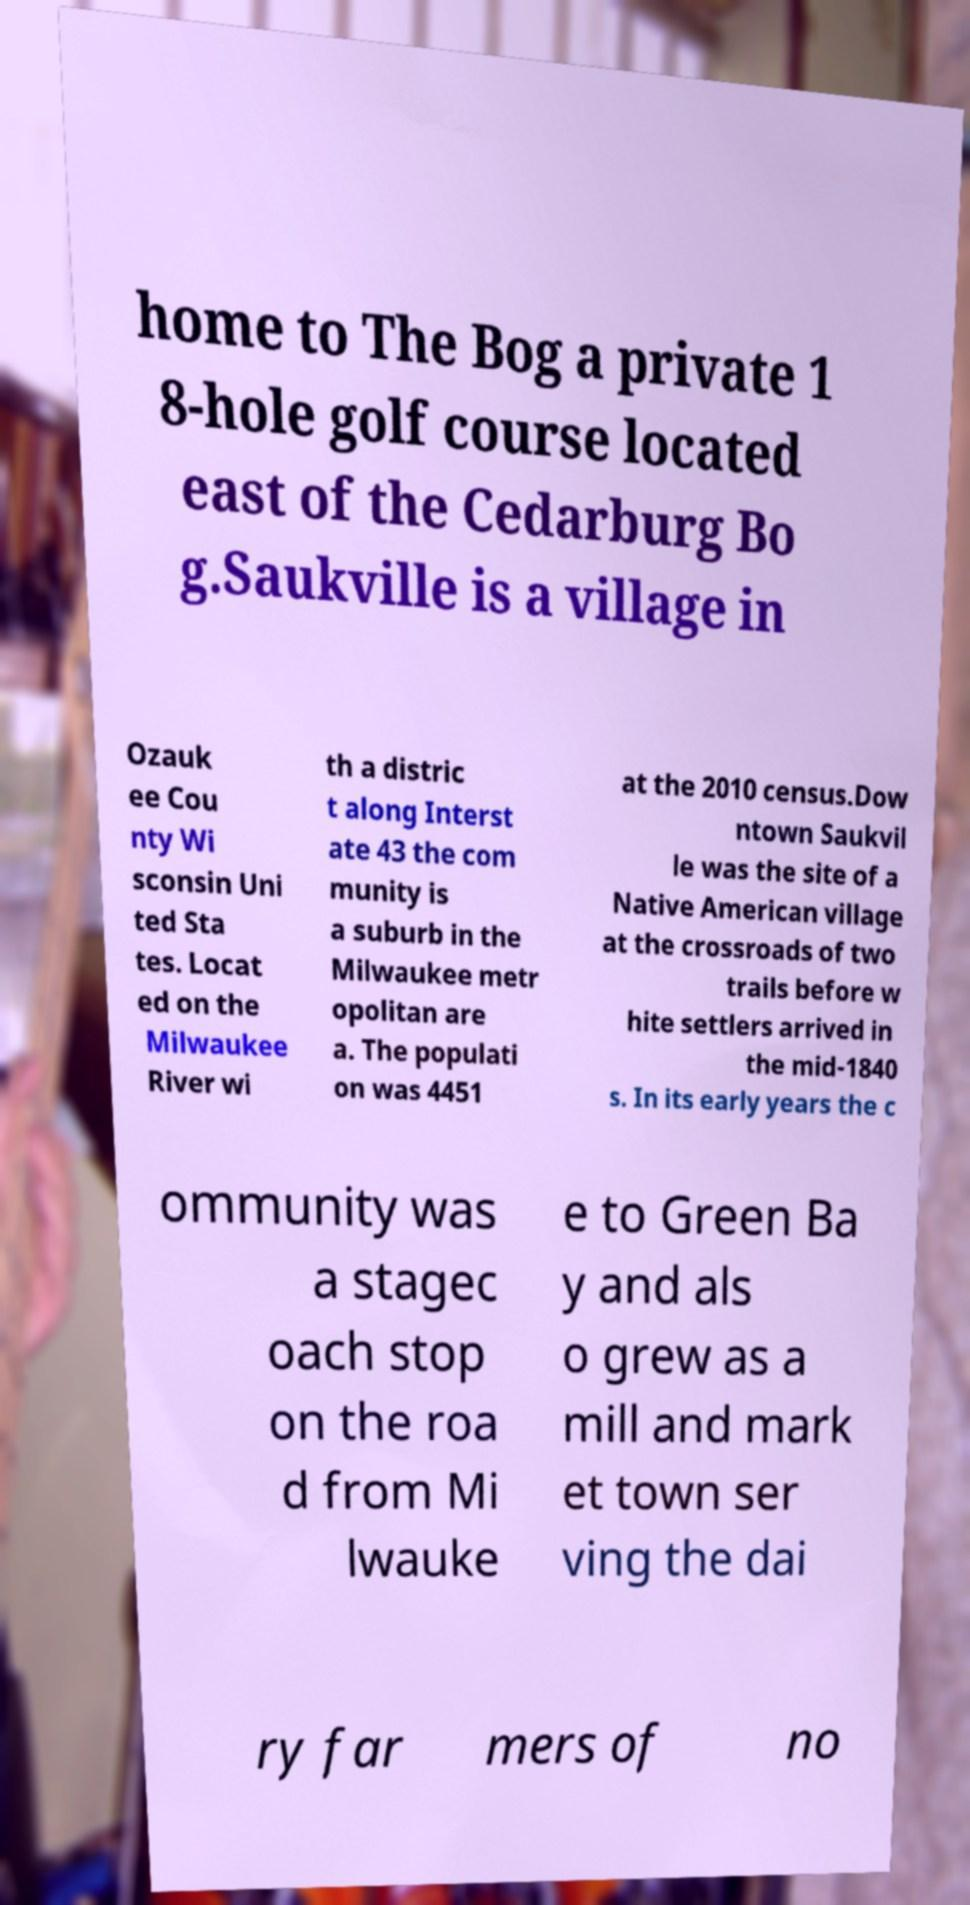Could you assist in decoding the text presented in this image and type it out clearly? home to The Bog a private 1 8-hole golf course located east of the Cedarburg Bo g.Saukville is a village in Ozauk ee Cou nty Wi sconsin Uni ted Sta tes. Locat ed on the Milwaukee River wi th a distric t along Interst ate 43 the com munity is a suburb in the Milwaukee metr opolitan are a. The populati on was 4451 at the 2010 census.Dow ntown Saukvil le was the site of a Native American village at the crossroads of two trails before w hite settlers arrived in the mid-1840 s. In its early years the c ommunity was a stagec oach stop on the roa d from Mi lwauke e to Green Ba y and als o grew as a mill and mark et town ser ving the dai ry far mers of no 